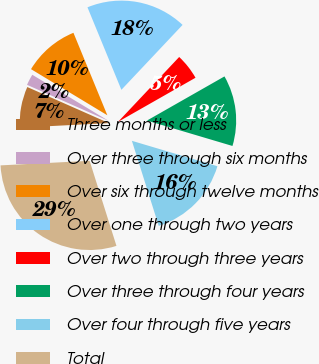Convert chart to OTSL. <chart><loc_0><loc_0><loc_500><loc_500><pie_chart><fcel>Three months or less<fcel>Over three through six months<fcel>Over six through twelve months<fcel>Over one through two years<fcel>Over two through three years<fcel>Over three through four years<fcel>Over four through five years<fcel>Total<nl><fcel>7.44%<fcel>2.03%<fcel>10.14%<fcel>18.24%<fcel>4.73%<fcel>12.84%<fcel>15.54%<fcel>29.05%<nl></chart> 